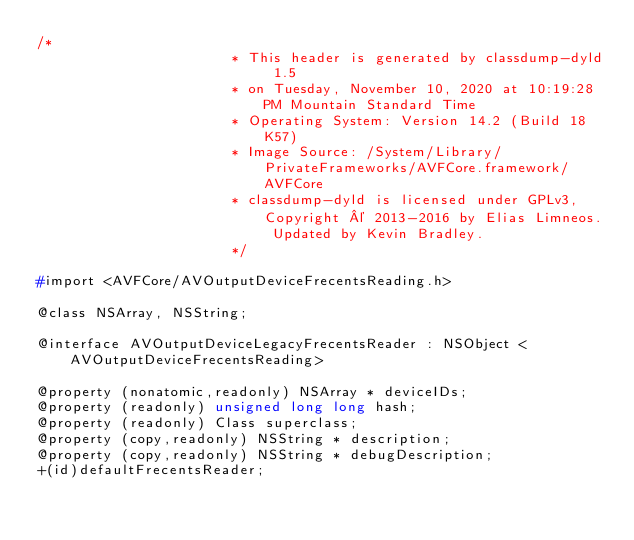Convert code to text. <code><loc_0><loc_0><loc_500><loc_500><_C_>/*
                       * This header is generated by classdump-dyld 1.5
                       * on Tuesday, November 10, 2020 at 10:19:28 PM Mountain Standard Time
                       * Operating System: Version 14.2 (Build 18K57)
                       * Image Source: /System/Library/PrivateFrameworks/AVFCore.framework/AVFCore
                       * classdump-dyld is licensed under GPLv3, Copyright © 2013-2016 by Elias Limneos. Updated by Kevin Bradley.
                       */

#import <AVFCore/AVOutputDeviceFrecentsReading.h>

@class NSArray, NSString;

@interface AVOutputDeviceLegacyFrecentsReader : NSObject <AVOutputDeviceFrecentsReading>

@property (nonatomic,readonly) NSArray * deviceIDs; 
@property (readonly) unsigned long long hash; 
@property (readonly) Class superclass; 
@property (copy,readonly) NSString * description; 
@property (copy,readonly) NSString * debugDescription; 
+(id)defaultFrecentsReader;</code> 